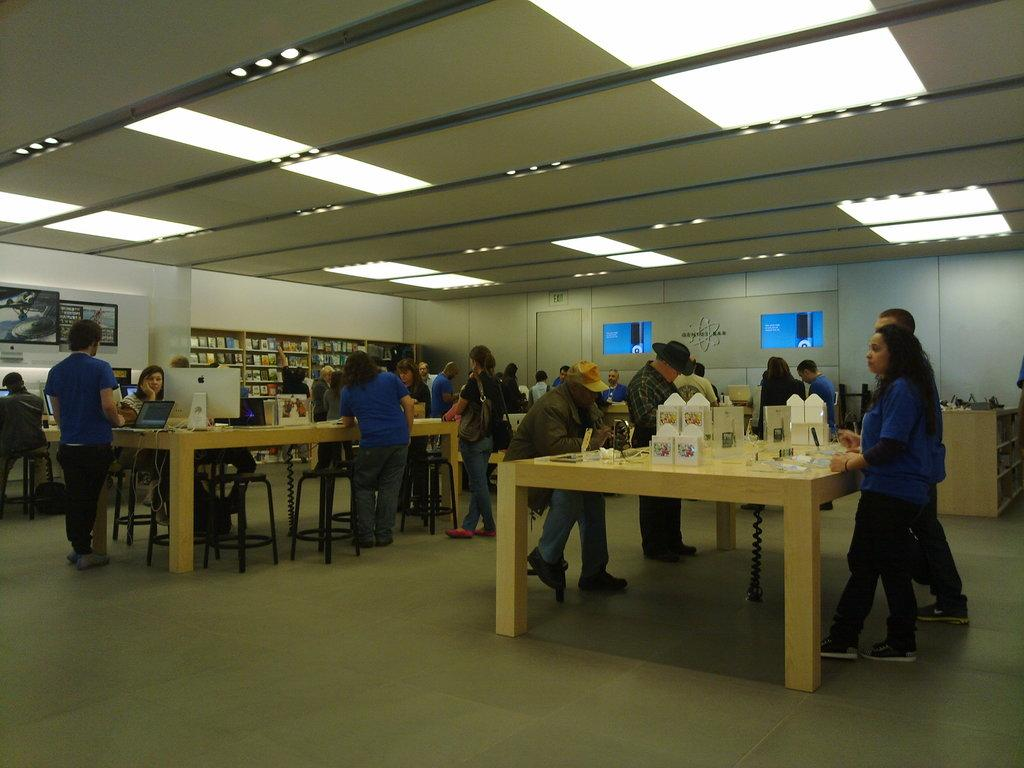What can be seen in the image involving people? There are people standing in the image. What is present on the table in the image? There are boxes, a monitor, and a laptop on the table. How many objects are on the table in the image? There are three objects on the table: boxes, a monitor, and a laptop. What type of playground equipment can be seen in the image? There is no playground equipment present in the image. What is the aftermath of the event depicted in the image? The image does not depict an event, so there is no aftermath to describe. 